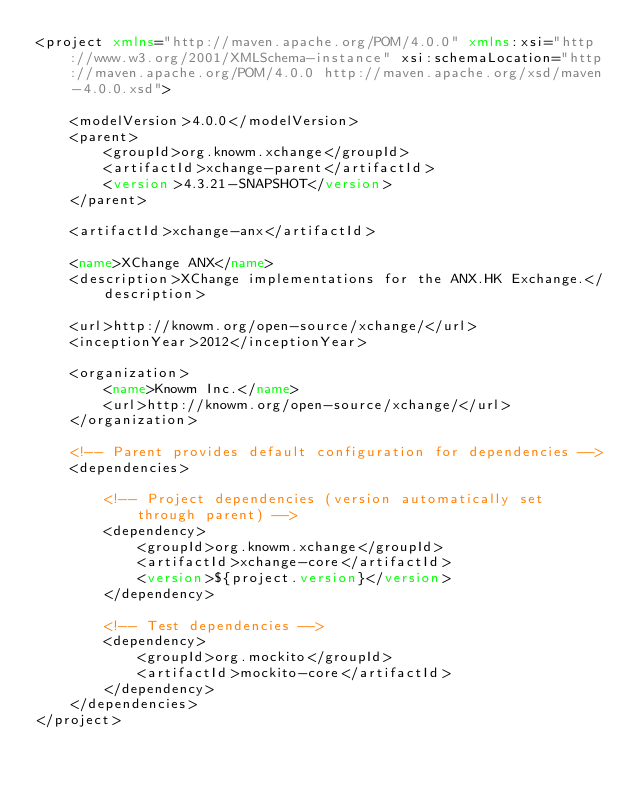Convert code to text. <code><loc_0><loc_0><loc_500><loc_500><_XML_><project xmlns="http://maven.apache.org/POM/4.0.0" xmlns:xsi="http://www.w3.org/2001/XMLSchema-instance" xsi:schemaLocation="http://maven.apache.org/POM/4.0.0 http://maven.apache.org/xsd/maven-4.0.0.xsd">

    <modelVersion>4.0.0</modelVersion>
    <parent>
        <groupId>org.knowm.xchange</groupId>
        <artifactId>xchange-parent</artifactId>
        <version>4.3.21-SNAPSHOT</version>
    </parent>

    <artifactId>xchange-anx</artifactId>

    <name>XChange ANX</name>
    <description>XChange implementations for the ANX.HK Exchange.</description>

    <url>http://knowm.org/open-source/xchange/</url>
    <inceptionYear>2012</inceptionYear>

    <organization>
        <name>Knowm Inc.</name>
        <url>http://knowm.org/open-source/xchange/</url>
    </organization>

    <!-- Parent provides default configuration for dependencies -->
    <dependencies>

        <!-- Project dependencies (version automatically set through parent) -->
        <dependency>
            <groupId>org.knowm.xchange</groupId>
            <artifactId>xchange-core</artifactId>
            <version>${project.version}</version>
        </dependency>

        <!-- Test dependencies -->
        <dependency>
            <groupId>org.mockito</groupId>
            <artifactId>mockito-core</artifactId>
        </dependency>
    </dependencies>
</project>
</code> 